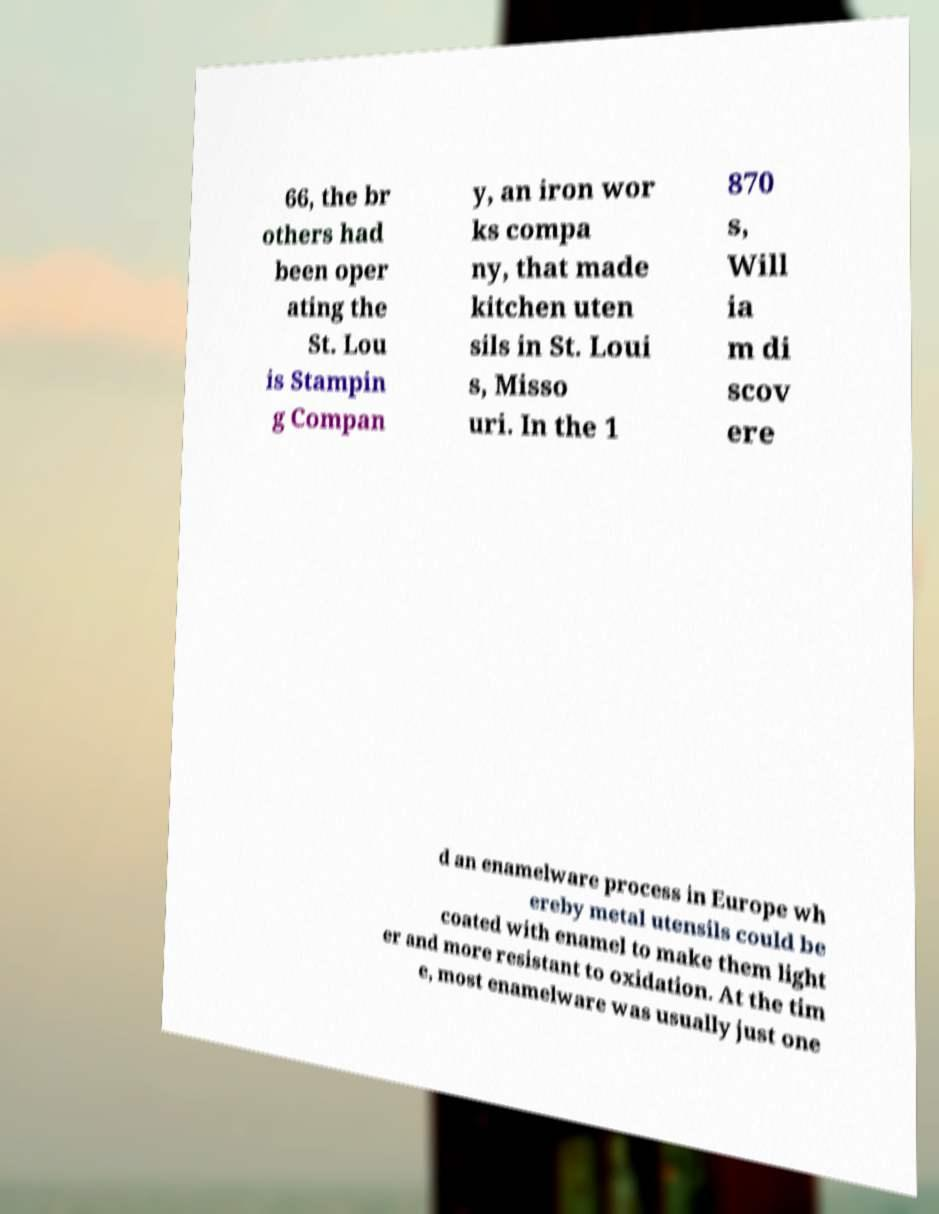Please identify and transcribe the text found in this image. 66, the br others had been oper ating the St. Lou is Stampin g Compan y, an iron wor ks compa ny, that made kitchen uten sils in St. Loui s, Misso uri. In the 1 870 s, Will ia m di scov ere d an enamelware process in Europe wh ereby metal utensils could be coated with enamel to make them light er and more resistant to oxidation. At the tim e, most enamelware was usually just one 